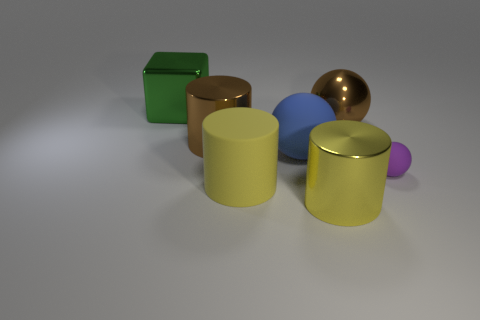Is there any other thing that has the same size as the purple sphere?
Provide a succinct answer. No. There is a big object that is the same color as the rubber cylinder; what is its material?
Keep it short and to the point. Metal. How many big blue objects have the same material as the green thing?
Your answer should be very brief. 0. There is a ball that is made of the same material as the big green block; what color is it?
Your response must be concise. Brown. What is the material of the large brown thing on the left side of the large brown metallic object that is behind the big metal cylinder behind the big yellow metal cylinder?
Your response must be concise. Metal. Is the size of the yellow cylinder that is on the right side of the blue matte ball the same as the big brown shiny ball?
Provide a short and direct response. Yes. How many tiny objects are either metal objects or yellow rubber cylinders?
Provide a succinct answer. 0. Are there any other big cylinders of the same color as the matte cylinder?
Your answer should be compact. Yes. There is a green thing that is the same size as the brown metal ball; what shape is it?
Make the answer very short. Cube. Is the color of the large metallic cylinder on the right side of the brown shiny cylinder the same as the matte cylinder?
Offer a very short reply. Yes. 